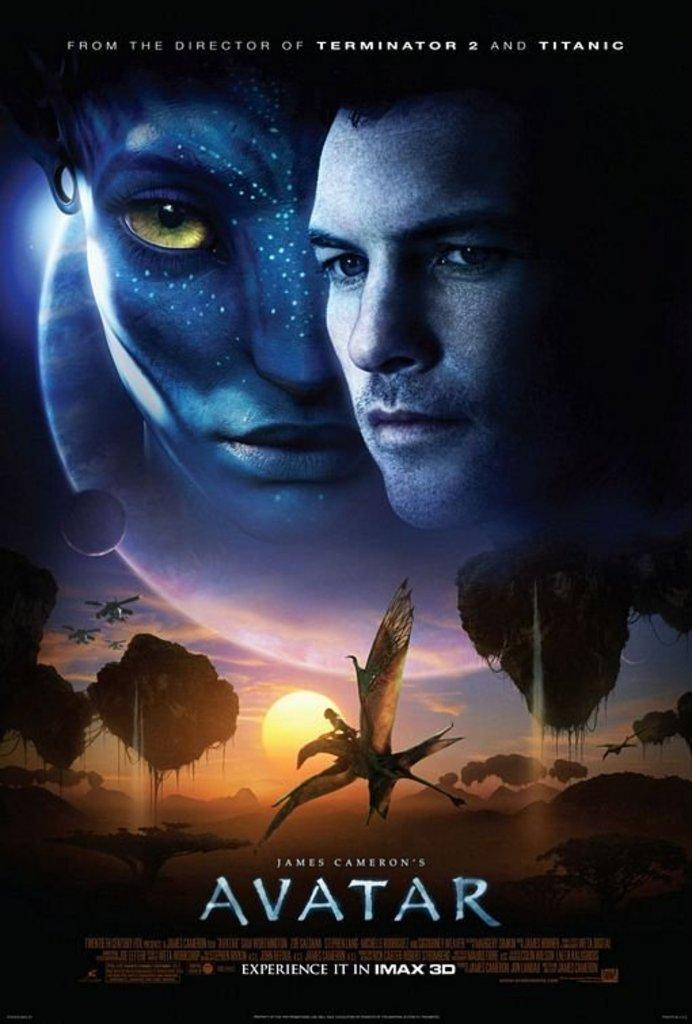Provide a one-sentence caption for the provided image. A poster for Avatar says that it will be in IMAX 3D. 